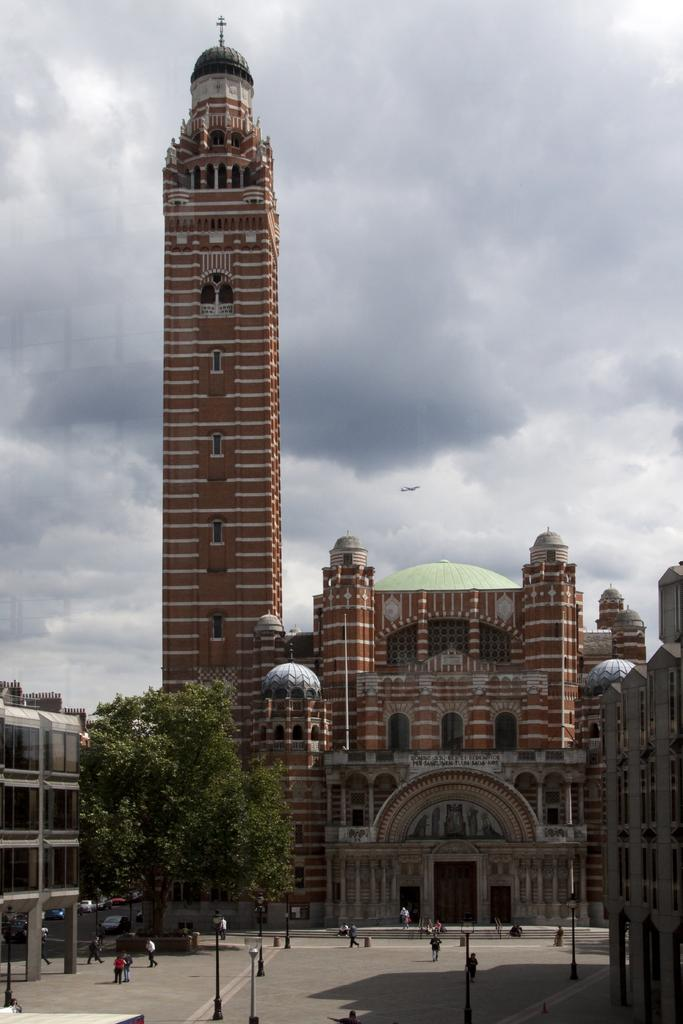What type of vegetation is on the left side of the image? There are trees on the left side of the image. What can be seen in the middle of the image? There are people in the middle of the image. What is visible in the background of the image? There is a building in the background of the image. What is visible at the top of the image? The sky is visible at the top of the image. What type of drug can be seen on the sidewalk in the image? There is no sidewalk or drug present in the image. Is there a field visible in the background of the image? No, there is no field visible in the image; there is a building in the background. 